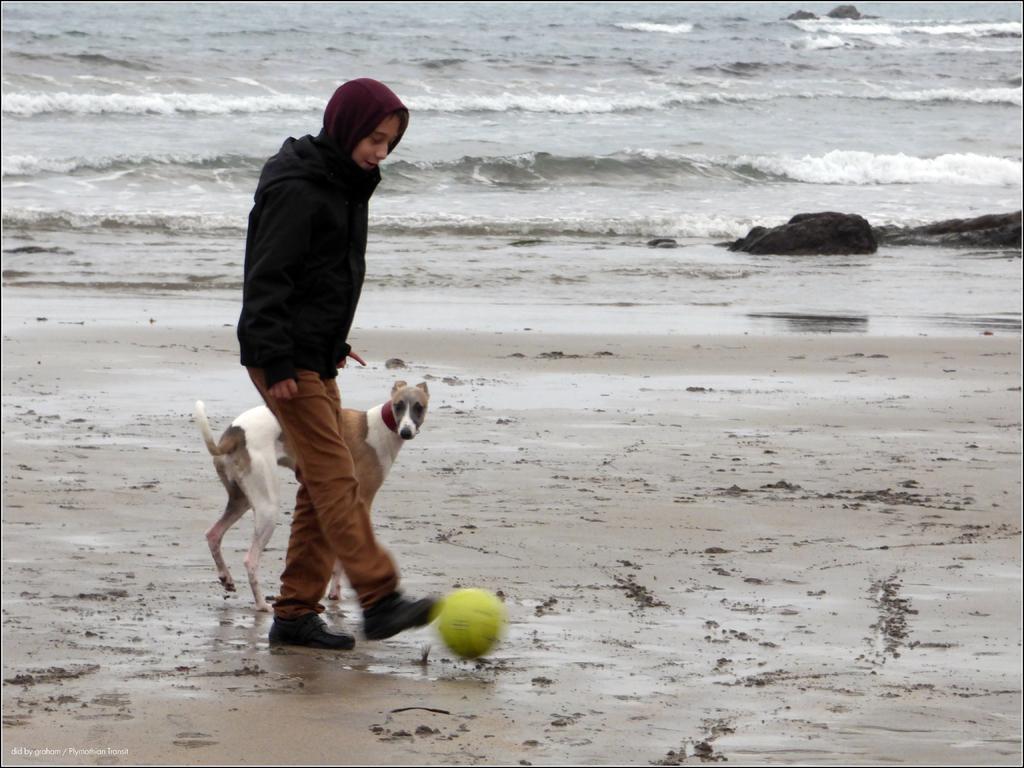Could you give a brief overview of what you see in this image? In this image I see a person who is wearing hoodie and brown color pants and I see a ball over here which is of green in color and I can also see a dog which is of white and brown in color and I see the sand. In the background I see the water and the rocks over here. 